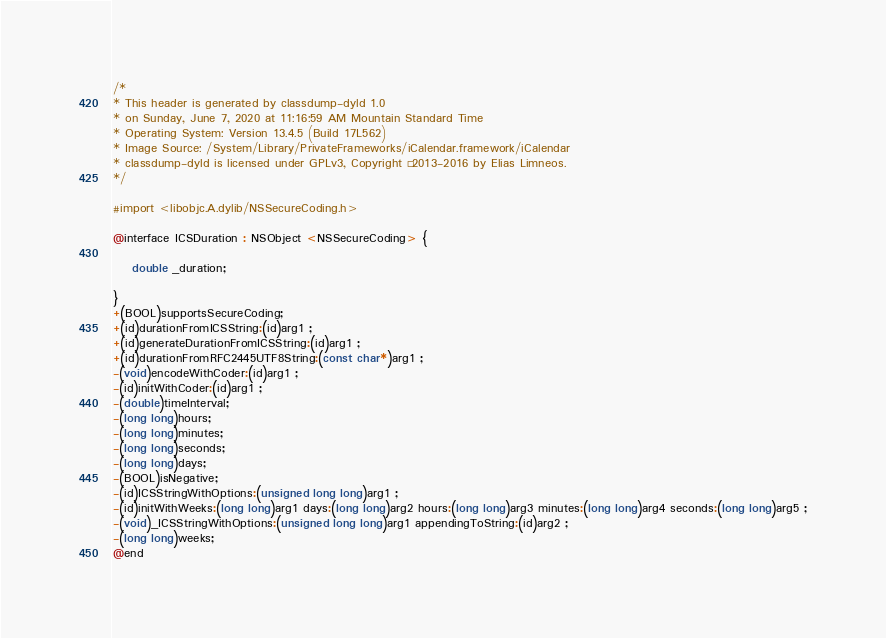Convert code to text. <code><loc_0><loc_0><loc_500><loc_500><_C_>/*
* This header is generated by classdump-dyld 1.0
* on Sunday, June 7, 2020 at 11:16:59 AM Mountain Standard Time
* Operating System: Version 13.4.5 (Build 17L562)
* Image Source: /System/Library/PrivateFrameworks/iCalendar.framework/iCalendar
* classdump-dyld is licensed under GPLv3, Copyright © 2013-2016 by Elias Limneos.
*/

#import <libobjc.A.dylib/NSSecureCoding.h>

@interface ICSDuration : NSObject <NSSecureCoding> {

	double _duration;

}
+(BOOL)supportsSecureCoding;
+(id)durationFromICSString:(id)arg1 ;
+(id)generateDurationFromICSString:(id)arg1 ;
+(id)durationFromRFC2445UTF8String:(const char*)arg1 ;
-(void)encodeWithCoder:(id)arg1 ;
-(id)initWithCoder:(id)arg1 ;
-(double)timeInterval;
-(long long)hours;
-(long long)minutes;
-(long long)seconds;
-(long long)days;
-(BOOL)isNegative;
-(id)ICSStringWithOptions:(unsigned long long)arg1 ;
-(id)initWithWeeks:(long long)arg1 days:(long long)arg2 hours:(long long)arg3 minutes:(long long)arg4 seconds:(long long)arg5 ;
-(void)_ICSStringWithOptions:(unsigned long long)arg1 appendingToString:(id)arg2 ;
-(long long)weeks;
@end

</code> 